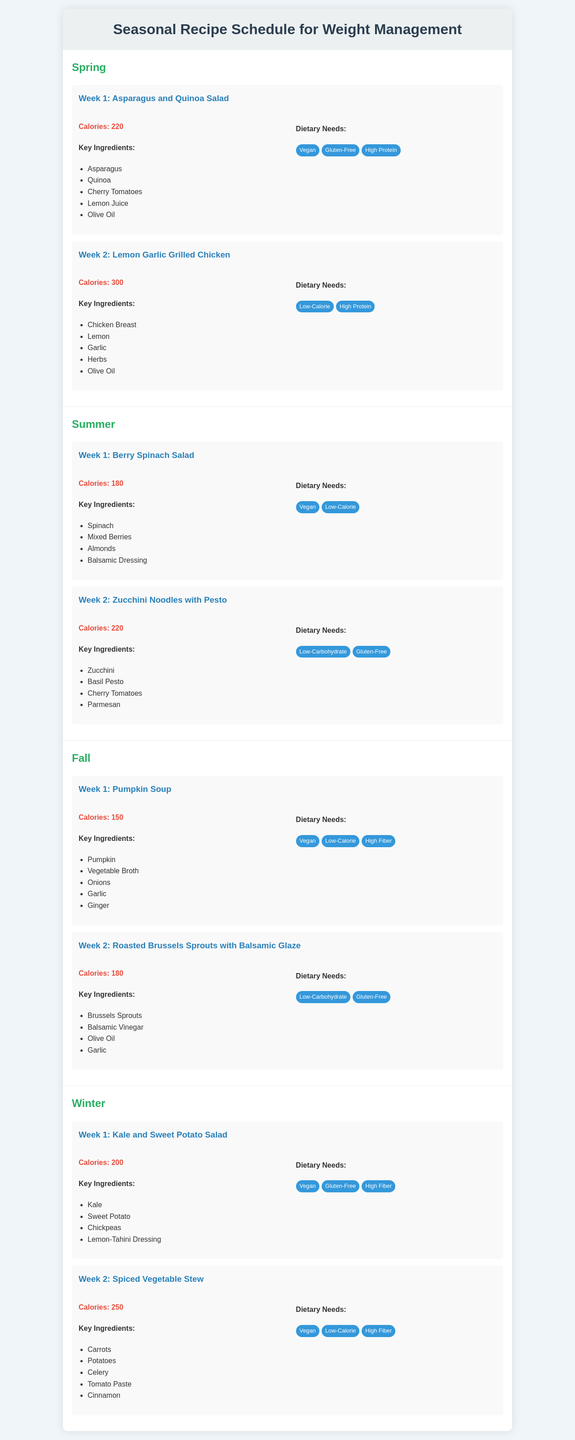What is the title of the document? The title is displayed prominently at the top of the document.
Answer: Seasonal Recipe Schedule for Weight Management How many recipes are listed in the Spring season? The Spring section contains two recipe weeks, each featuring a recipe.
Answer: 2 What is the calorie count of the Lemon Garlic Grilled Chicken? The calorie count is specified in the recipe details for this dish.
Answer: 300 Which dietary needs are associated with the Berry Spinach Salad? Specific dietary needs are listed for each recipe; this includes various requirements.
Answer: Vegan, Low-Calorie What is the key ingredient in the Pumpkin Soup? Key ingredients are listed for each recipe; identifying one of them provides the answer.
Answer: Pumpkin Which recipe is featured in the second week of Winter? Each week of each season has a specific recipe assigned to it.
Answer: Spiced Vegetable Stew What is the calorie count of the Roasted Brussels Sprouts with Balsamic Glaze? The calorie count is mentioned in the recipe details of this dish.
Answer: 180 How many dietary needs are listed for the Kale and Sweet Potato Salad? The dietary needs section provides a set number of requirements related to the dish.
Answer: 3 